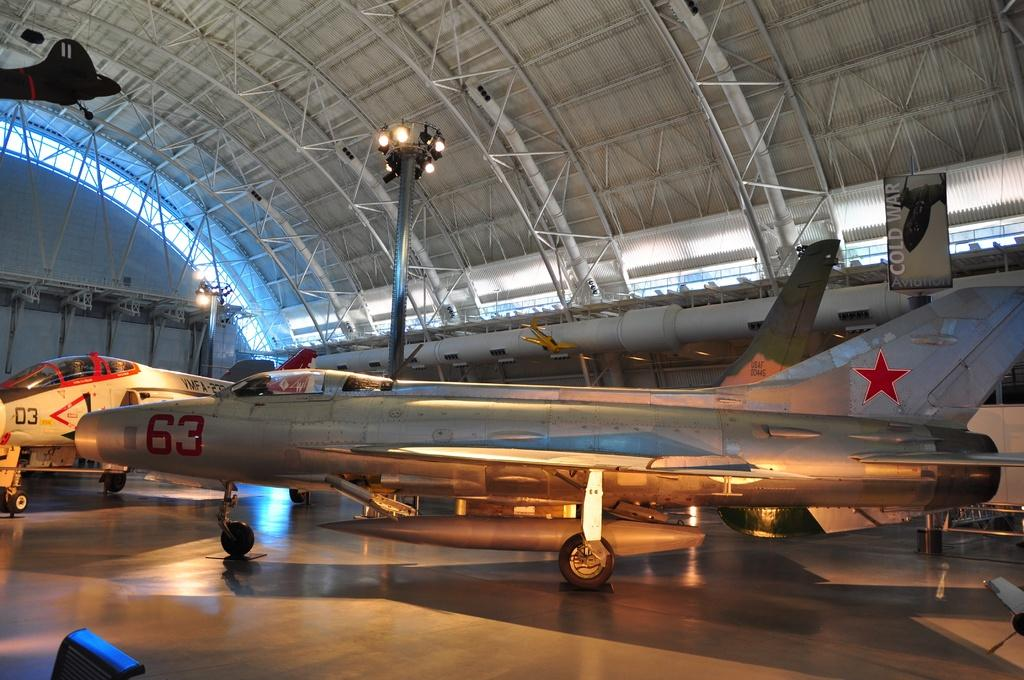<image>
Present a compact description of the photo's key features. A silver jet with the number 63 on the side of the front. 